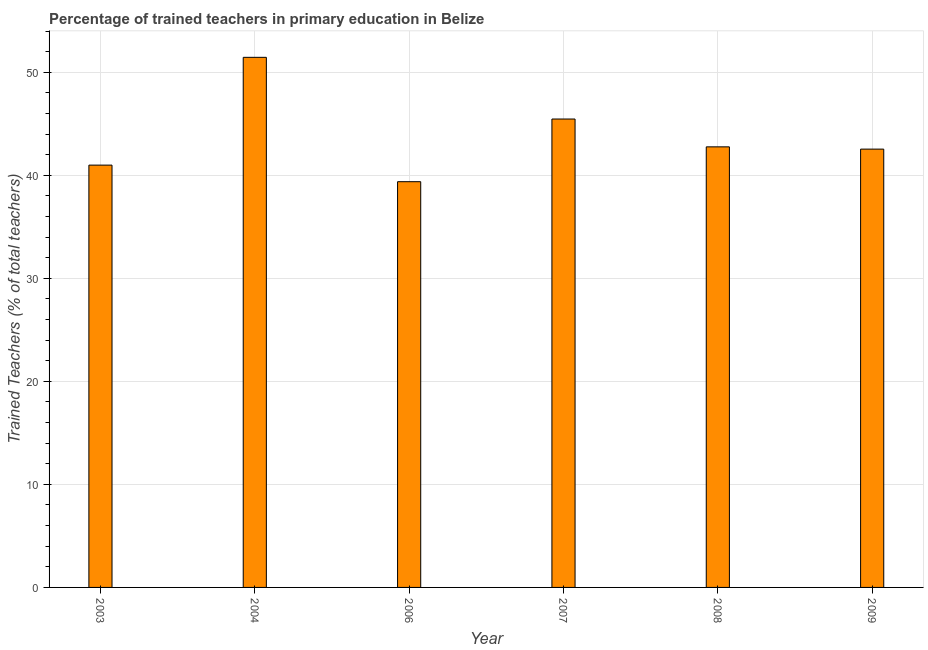Does the graph contain grids?
Your answer should be compact. Yes. What is the title of the graph?
Your response must be concise. Percentage of trained teachers in primary education in Belize. What is the label or title of the X-axis?
Ensure brevity in your answer.  Year. What is the label or title of the Y-axis?
Ensure brevity in your answer.  Trained Teachers (% of total teachers). What is the percentage of trained teachers in 2004?
Your answer should be compact. 51.45. Across all years, what is the maximum percentage of trained teachers?
Provide a succinct answer. 51.45. Across all years, what is the minimum percentage of trained teachers?
Ensure brevity in your answer.  39.38. What is the sum of the percentage of trained teachers?
Keep it short and to the point. 262.56. What is the difference between the percentage of trained teachers in 2007 and 2008?
Ensure brevity in your answer.  2.7. What is the average percentage of trained teachers per year?
Make the answer very short. 43.76. What is the median percentage of trained teachers?
Ensure brevity in your answer.  42.65. In how many years, is the percentage of trained teachers greater than 2 %?
Provide a short and direct response. 6. Do a majority of the years between 2003 and 2009 (inclusive) have percentage of trained teachers greater than 28 %?
Provide a short and direct response. Yes. What is the ratio of the percentage of trained teachers in 2007 to that in 2008?
Offer a very short reply. 1.06. Is the percentage of trained teachers in 2003 less than that in 2009?
Ensure brevity in your answer.  Yes. What is the difference between the highest and the second highest percentage of trained teachers?
Offer a terse response. 5.99. What is the difference between the highest and the lowest percentage of trained teachers?
Your answer should be compact. 12.07. In how many years, is the percentage of trained teachers greater than the average percentage of trained teachers taken over all years?
Ensure brevity in your answer.  2. Are all the bars in the graph horizontal?
Offer a terse response. No. What is the Trained Teachers (% of total teachers) of 2003?
Provide a succinct answer. 40.99. What is the Trained Teachers (% of total teachers) of 2004?
Offer a very short reply. 51.45. What is the Trained Teachers (% of total teachers) in 2006?
Keep it short and to the point. 39.38. What is the Trained Teachers (% of total teachers) of 2007?
Your answer should be compact. 45.46. What is the Trained Teachers (% of total teachers) in 2008?
Your answer should be very brief. 42.76. What is the Trained Teachers (% of total teachers) in 2009?
Keep it short and to the point. 42.54. What is the difference between the Trained Teachers (% of total teachers) in 2003 and 2004?
Your answer should be compact. -10.46. What is the difference between the Trained Teachers (% of total teachers) in 2003 and 2006?
Offer a terse response. 1.61. What is the difference between the Trained Teachers (% of total teachers) in 2003 and 2007?
Provide a short and direct response. -4.47. What is the difference between the Trained Teachers (% of total teachers) in 2003 and 2008?
Provide a succinct answer. -1.77. What is the difference between the Trained Teachers (% of total teachers) in 2003 and 2009?
Your answer should be compact. -1.55. What is the difference between the Trained Teachers (% of total teachers) in 2004 and 2006?
Ensure brevity in your answer.  12.07. What is the difference between the Trained Teachers (% of total teachers) in 2004 and 2007?
Provide a succinct answer. 5.99. What is the difference between the Trained Teachers (% of total teachers) in 2004 and 2008?
Your answer should be compact. 8.69. What is the difference between the Trained Teachers (% of total teachers) in 2004 and 2009?
Offer a terse response. 8.91. What is the difference between the Trained Teachers (% of total teachers) in 2006 and 2007?
Provide a succinct answer. -6.08. What is the difference between the Trained Teachers (% of total teachers) in 2006 and 2008?
Your response must be concise. -3.38. What is the difference between the Trained Teachers (% of total teachers) in 2006 and 2009?
Offer a terse response. -3.16. What is the difference between the Trained Teachers (% of total teachers) in 2007 and 2008?
Ensure brevity in your answer.  2.7. What is the difference between the Trained Teachers (% of total teachers) in 2007 and 2009?
Make the answer very short. 2.92. What is the difference between the Trained Teachers (% of total teachers) in 2008 and 2009?
Your answer should be very brief. 0.22. What is the ratio of the Trained Teachers (% of total teachers) in 2003 to that in 2004?
Offer a terse response. 0.8. What is the ratio of the Trained Teachers (% of total teachers) in 2003 to that in 2006?
Your answer should be very brief. 1.04. What is the ratio of the Trained Teachers (% of total teachers) in 2003 to that in 2007?
Keep it short and to the point. 0.9. What is the ratio of the Trained Teachers (% of total teachers) in 2003 to that in 2009?
Your answer should be very brief. 0.96. What is the ratio of the Trained Teachers (% of total teachers) in 2004 to that in 2006?
Offer a very short reply. 1.31. What is the ratio of the Trained Teachers (% of total teachers) in 2004 to that in 2007?
Ensure brevity in your answer.  1.13. What is the ratio of the Trained Teachers (% of total teachers) in 2004 to that in 2008?
Make the answer very short. 1.2. What is the ratio of the Trained Teachers (% of total teachers) in 2004 to that in 2009?
Provide a succinct answer. 1.21. What is the ratio of the Trained Teachers (% of total teachers) in 2006 to that in 2007?
Your answer should be very brief. 0.87. What is the ratio of the Trained Teachers (% of total teachers) in 2006 to that in 2008?
Provide a succinct answer. 0.92. What is the ratio of the Trained Teachers (% of total teachers) in 2006 to that in 2009?
Provide a succinct answer. 0.93. What is the ratio of the Trained Teachers (% of total teachers) in 2007 to that in 2008?
Offer a terse response. 1.06. What is the ratio of the Trained Teachers (% of total teachers) in 2007 to that in 2009?
Offer a terse response. 1.07. 